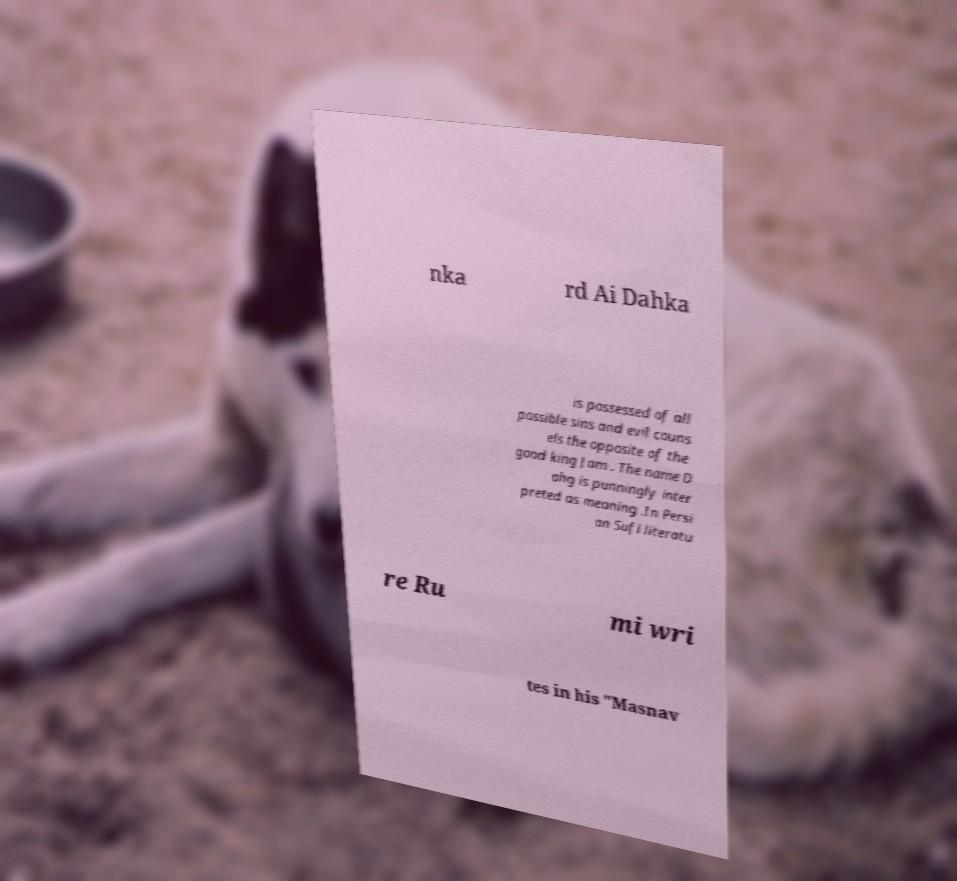What messages or text are displayed in this image? I need them in a readable, typed format. nka rd Ai Dahka is possessed of all possible sins and evil couns els the opposite of the good king Jam . The name D ahg is punningly inter preted as meaning .In Persi an Sufi literatu re Ru mi wri tes in his "Masnav 